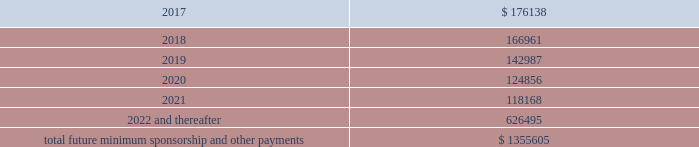2016 , as well as significant sponsorship and other marketing agreements entered into during the period after december 31 , 2016 through the date of this report : ( in thousands ) .
Total future minimum sponsorship and other payments $ 1355605 the amounts listed above are the minimum compensation obligations and guaranteed royalty fees required to be paid under the company 2019s sponsorship and other marketing agreements .
The amounts listed above do not include additional performance incentives and product supply obligations provided under certain agreements .
It is not possible to determine how much the company will spend on product supply obligations on an annual basis as contracts generally do not stipulate specific cash amounts to be spent on products .
The amount of product provided to the sponsorships depends on many factors including general playing conditions , the number of sporting events in which they participate and the company 2019s decisions regarding product and marketing initiatives .
In addition , the costs to design , develop , source and purchase the products furnished to the endorsers are incurred over a period of time and are not necessarily tracked separately from similar costs incurred for products sold to customers .
In connection with various contracts and agreements , the company has agreed to indemnify counterparties against certain third party claims relating to the infringement of intellectual property rights and other items .
Generally , such indemnification obligations do not apply in situations in which the counterparties are grossly negligent , engage in willful misconduct , or act in bad faith .
Based on the company 2019s historical experience and the estimated probability of future loss , the company has determined that the fair value of such indemnifications is not material to its consolidated financial position or results of operations .
From time to time , the company is involved in litigation and other proceedings , including matters related to commercial and intellectual property disputes , as well as trade , regulatory and other claims related to its business .
Other than as described below , the company believes that all current proceedings are routine in nature and incidental to the conduct of its business , and that the ultimate resolution of any such proceedings will not have a material adverse effect on its consolidated financial position , results of operations or cash flows .
On february 10 , 2017 , a shareholder filed a securities case in the united states district court for the district of maryland ( the 201ccourt 201d ) against the company , the company 2019s chief executive officer and the company 2019s former chief financial officer ( brian breece v .
Under armour , inc. ) .
On february 16 , 2017 , a second shareholder filed a securities case in the court against the same defendants ( jodie hopkins v .
Under armour , inc. ) .
The plaintiff in each case purports to represent a class of shareholders for the period between april 21 , 2016 and january 30 , 2017 , inclusive .
The complaints allege violations of section 10 ( b ) ( and rule 10b-5 ) of the securities exchange act of 1934 , as amended ( the 201cexchange act 201d ) and section 20 ( a ) control person liability under the exchange act against the officers named in the complaints .
In general , the allegations in each case concern disclosures and statements made by .
What portion of the total future minimum sponsorship and other payments will be due in the next three years? 
Computations: (((176138 + 166961) + 142987) / 1355605)
Answer: 0.35857. 